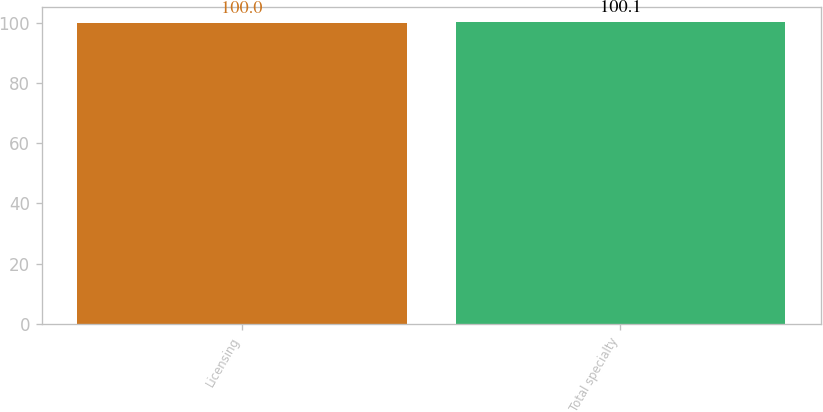Convert chart. <chart><loc_0><loc_0><loc_500><loc_500><bar_chart><fcel>Licensing<fcel>Total specialty<nl><fcel>100<fcel>100.1<nl></chart> 